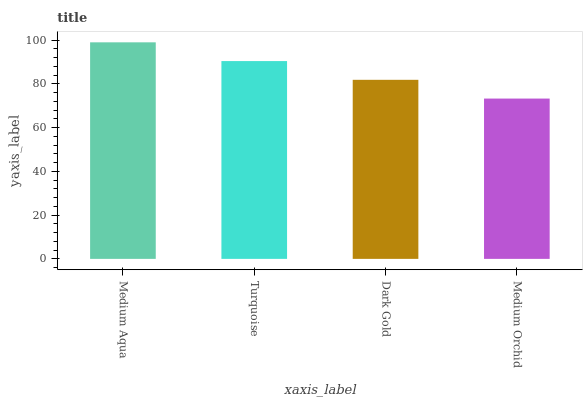Is Turquoise the minimum?
Answer yes or no. No. Is Turquoise the maximum?
Answer yes or no. No. Is Medium Aqua greater than Turquoise?
Answer yes or no. Yes. Is Turquoise less than Medium Aqua?
Answer yes or no. Yes. Is Turquoise greater than Medium Aqua?
Answer yes or no. No. Is Medium Aqua less than Turquoise?
Answer yes or no. No. Is Turquoise the high median?
Answer yes or no. Yes. Is Dark Gold the low median?
Answer yes or no. Yes. Is Medium Aqua the high median?
Answer yes or no. No. Is Medium Orchid the low median?
Answer yes or no. No. 